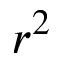<formula> <loc_0><loc_0><loc_500><loc_500>r ^ { 2 }</formula> 